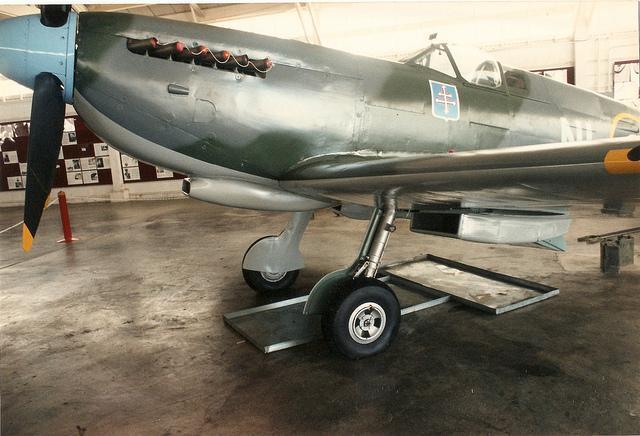How many horses are in the photo?
Give a very brief answer. 0. 